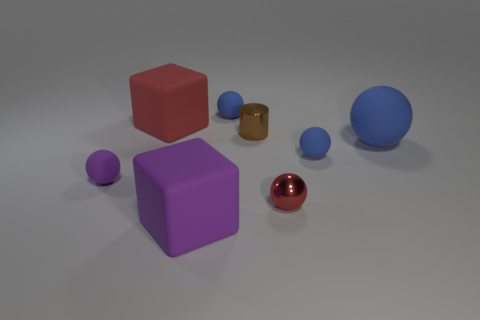Subtract all metal spheres. How many spheres are left? 4 Add 1 large matte spheres. How many objects exist? 9 Subtract all red spheres. How many spheres are left? 4 Subtract 3 balls. How many balls are left? 2 Subtract all cyan cylinders. How many brown spheres are left? 0 Subtract all red metallic balls. Subtract all small red metal spheres. How many objects are left? 6 Add 7 tiny purple things. How many tiny purple things are left? 8 Add 5 rubber cubes. How many rubber cubes exist? 7 Subtract 1 purple blocks. How many objects are left? 7 Subtract all balls. How many objects are left? 3 